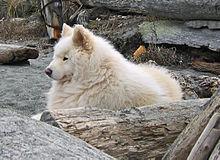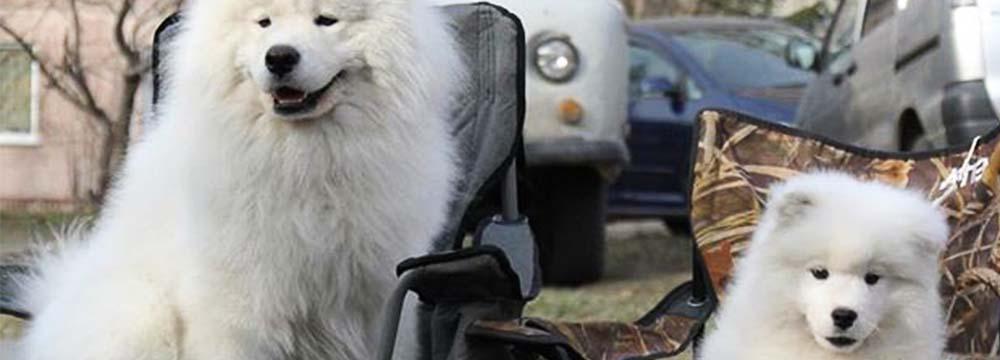The first image is the image on the left, the second image is the image on the right. Considering the images on both sides, is "Each image contains a single white dog, and at least one image features a dog standing on all fours with its body turned leftward." valid? Answer yes or no. No. The first image is the image on the left, the second image is the image on the right. Evaluate the accuracy of this statement regarding the images: "One of the images features a dog eating at a dinner table.". Is it true? Answer yes or no. No. 